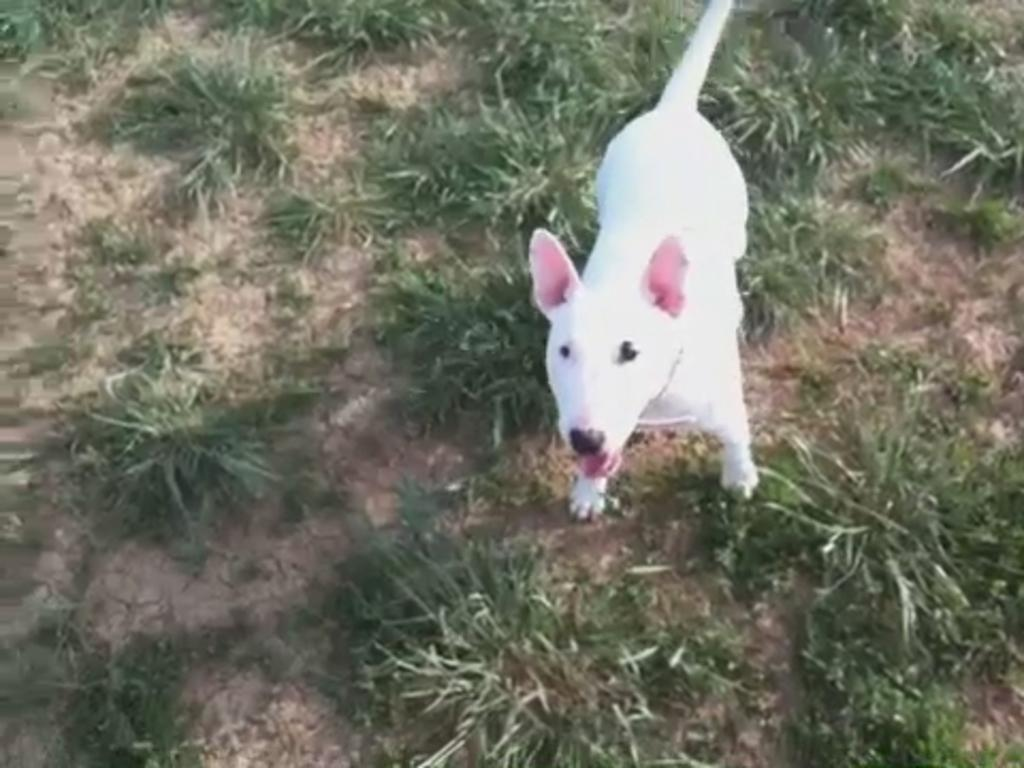What type of animal is in the image? There is a dog in the image. What is the ground made of in the image? There is grass on the ground in the image. How many leaves are on the dog in the image? There are no leaves present on the dog in the image. 